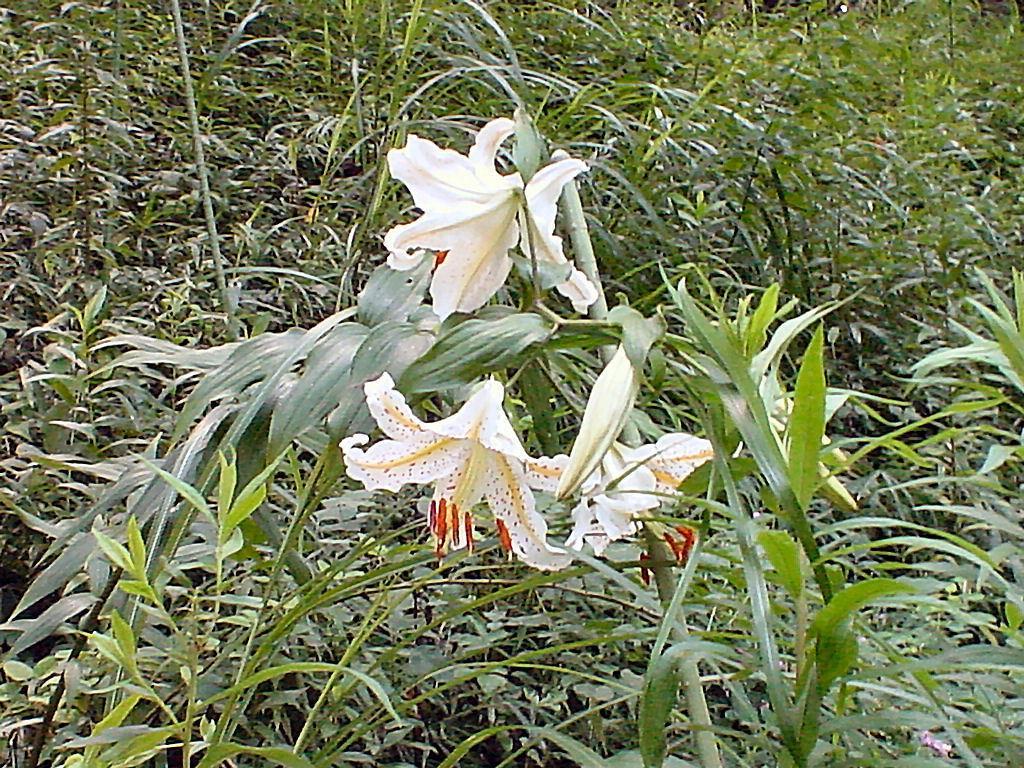Describe this image in one or two sentences. In this image I can see few plants which are green in color and few flowers which are white, cream and red in color. In the background I can see few plants. 